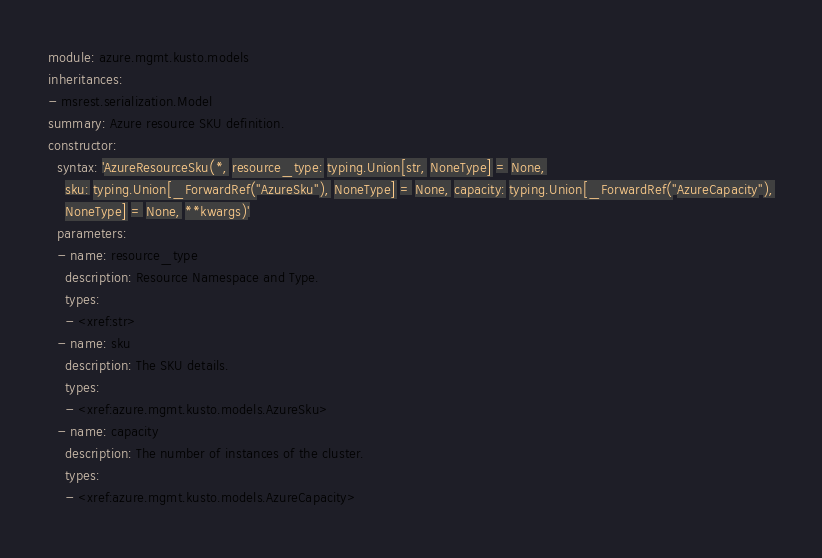<code> <loc_0><loc_0><loc_500><loc_500><_YAML_>module: azure.mgmt.kusto.models
inheritances:
- msrest.serialization.Model
summary: Azure resource SKU definition.
constructor:
  syntax: 'AzureResourceSku(*, resource_type: typing.Union[str, NoneType] = None,
    sku: typing.Union[_ForwardRef(''AzureSku''), NoneType] = None, capacity: typing.Union[_ForwardRef(''AzureCapacity''),
    NoneType] = None, **kwargs)'
  parameters:
  - name: resource_type
    description: Resource Namespace and Type.
    types:
    - <xref:str>
  - name: sku
    description: The SKU details.
    types:
    - <xref:azure.mgmt.kusto.models.AzureSku>
  - name: capacity
    description: The number of instances of the cluster.
    types:
    - <xref:azure.mgmt.kusto.models.AzureCapacity>
</code> 